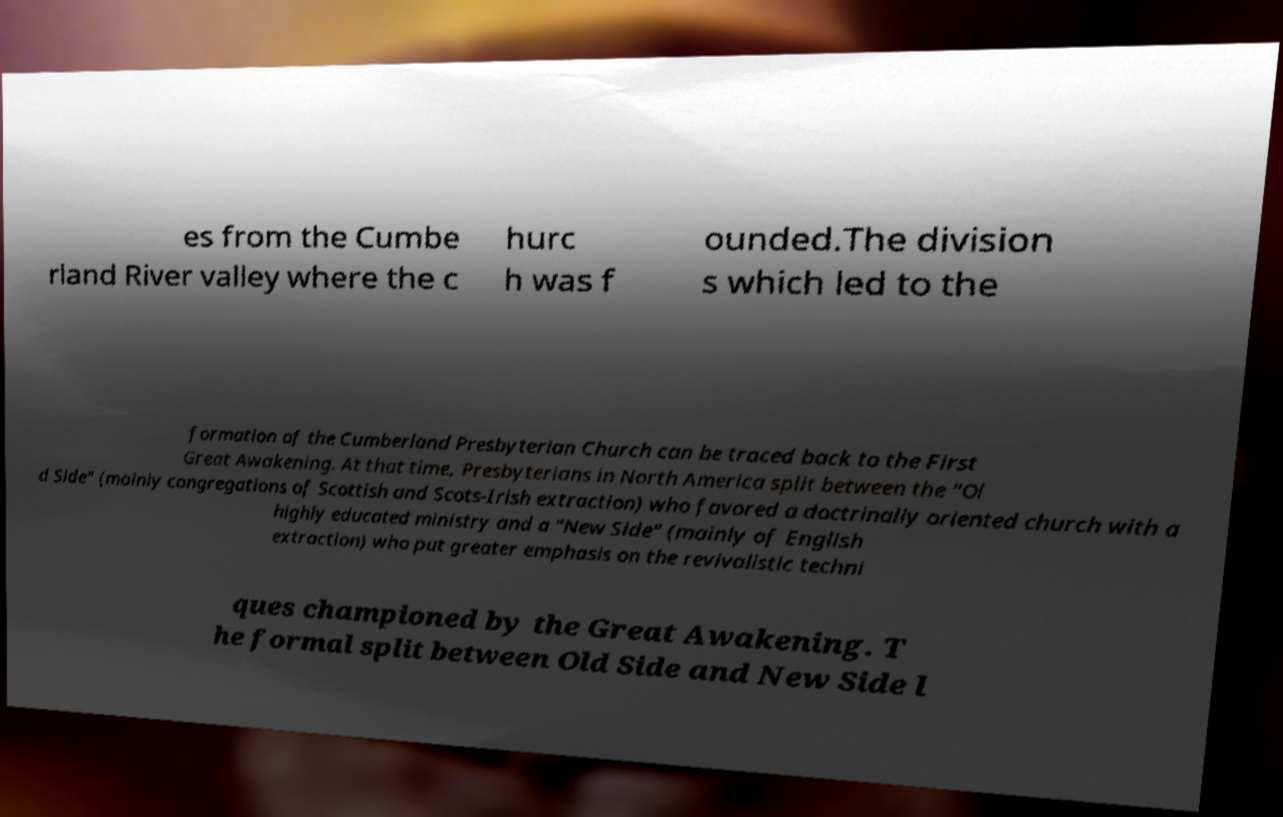There's text embedded in this image that I need extracted. Can you transcribe it verbatim? es from the Cumbe rland River valley where the c hurc h was f ounded.The division s which led to the formation of the Cumberland Presbyterian Church can be traced back to the First Great Awakening. At that time, Presbyterians in North America split between the "Ol d Side" (mainly congregations of Scottish and Scots-Irish extraction) who favored a doctrinally oriented church with a highly educated ministry and a "New Side" (mainly of English extraction) who put greater emphasis on the revivalistic techni ques championed by the Great Awakening. T he formal split between Old Side and New Side l 